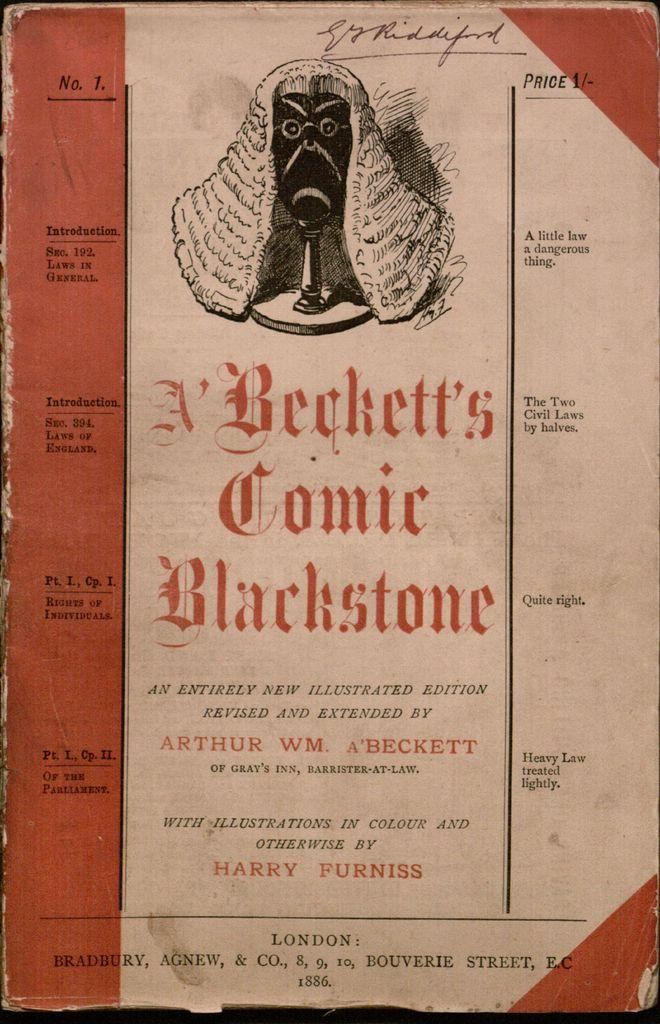<image>
Give a short and clear explanation of the subsequent image. An old book by Arthur Beckett that is illustrated. 